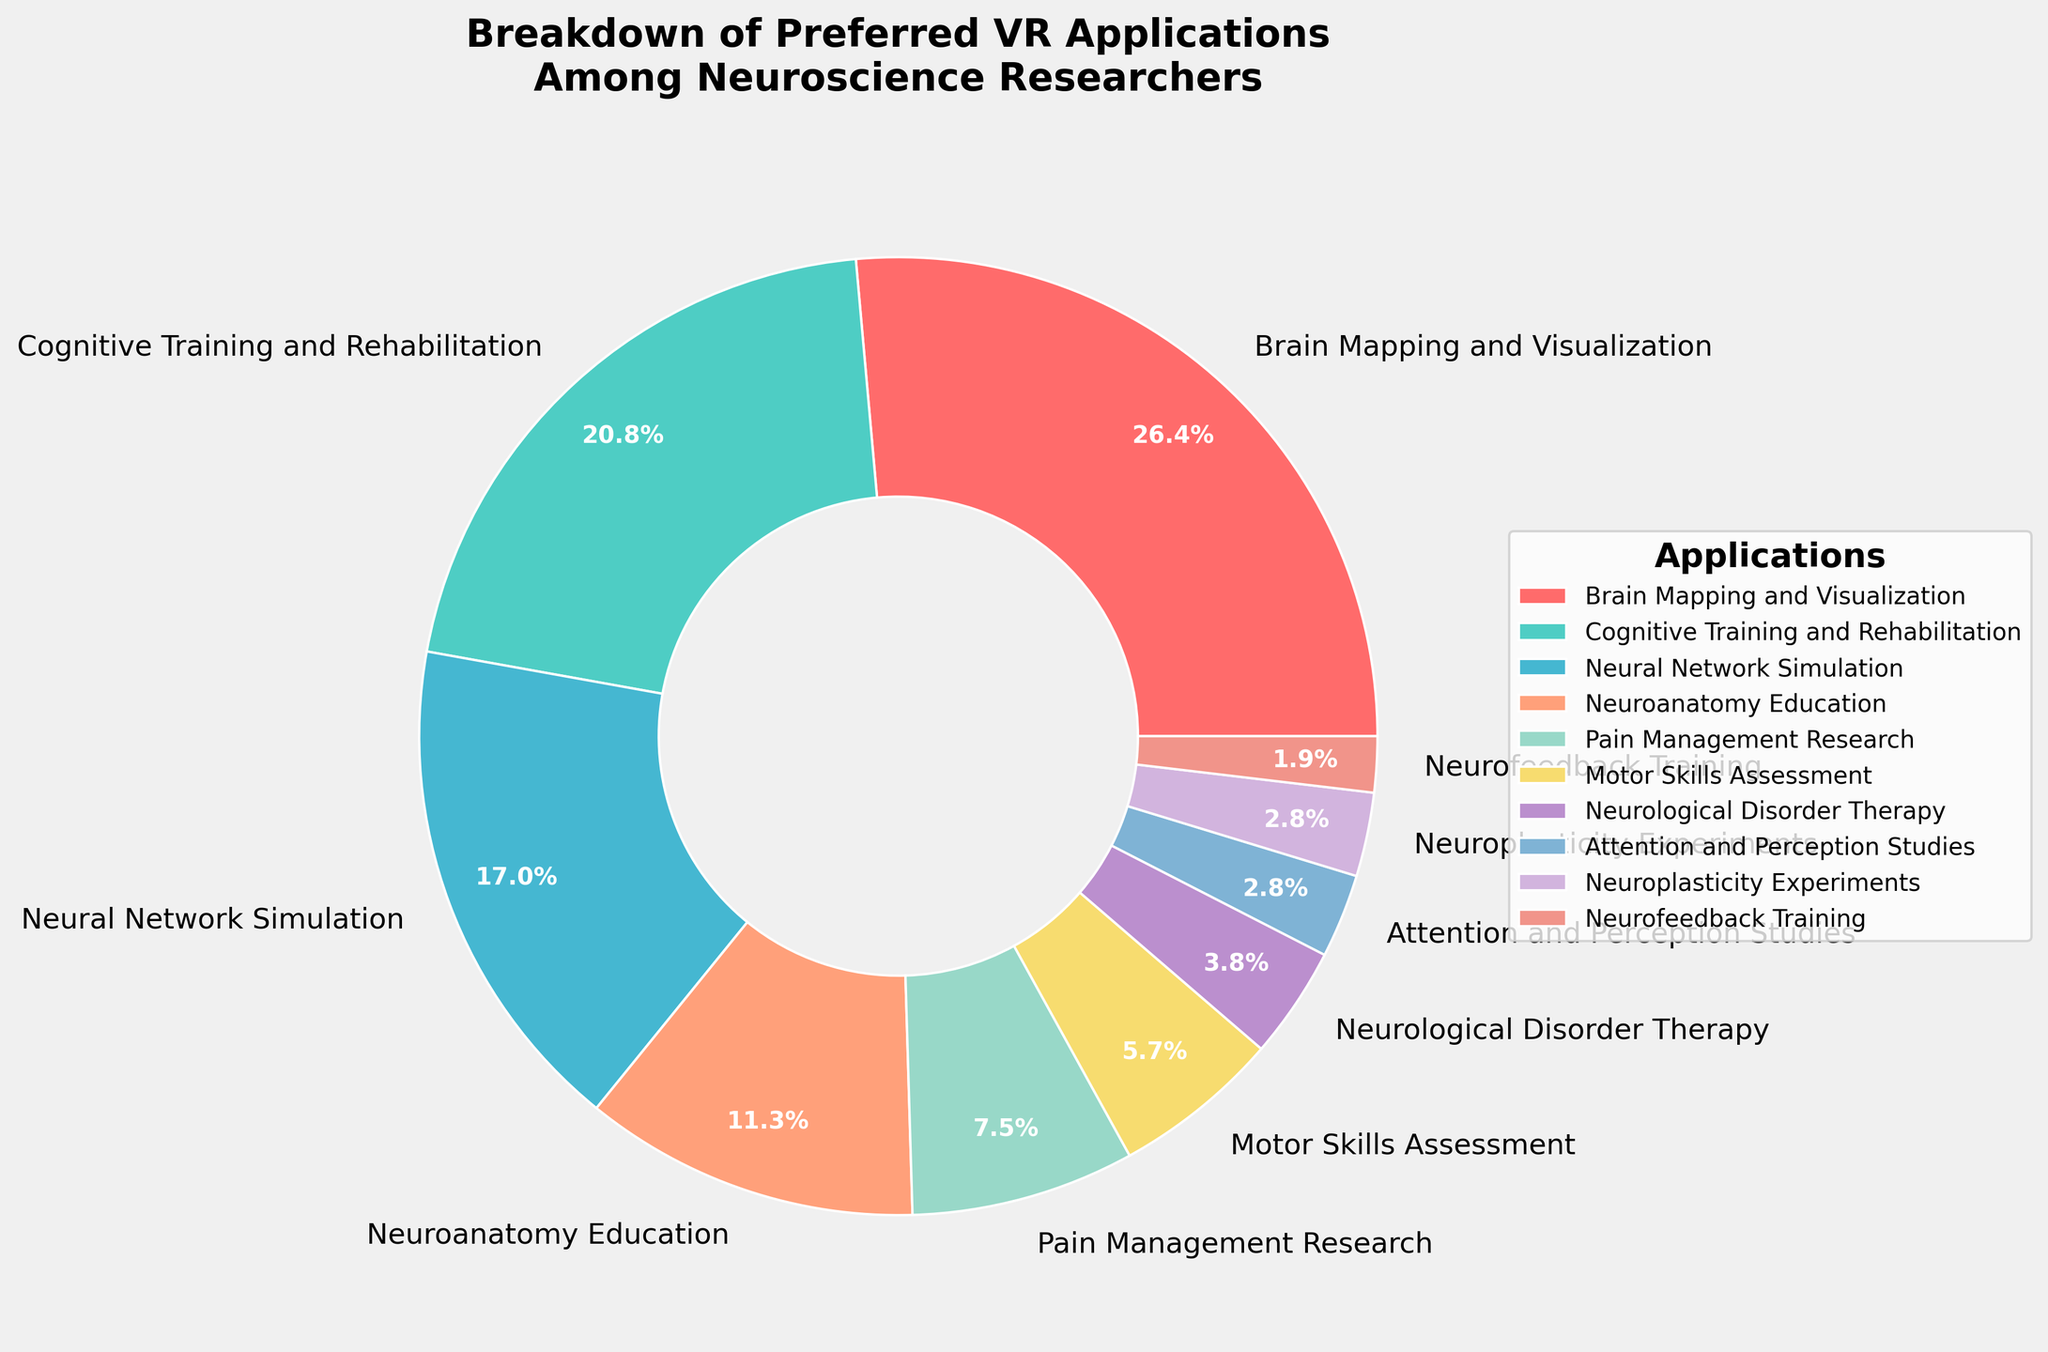What application has the highest percentage of preference among neuroscience researchers? To find this, look for the largest segment in the pie chart or the label with the highest percentage. Here, "Brain Mapping and Visualization" has the largest segment labeled 28%.
Answer: Brain Mapping and Visualization Which application category has a smaller preference than "Pain Management Research" but a larger preference than "Neurological Disorder Therapy"? "Pain Management Research" has a percentage of 8%. Categories smaller than this but larger than 4% (Neurological Disorder Therapy) will be "Motor Skills Assessment" with 6%.
Answer: Motor Skills Assessment What is the total percentage of preference for cognitive-focused applications (Cognitive Training and Rehabilitation, Attention and Perception Studies, and Neurofeedback Training)? Sum the percentages for these applications: Cognitive Training and Rehabilitation (22%), Attention and Perception Studies (3%), and Neurofeedback Training (2%). 22 + 3 + 2 = 27%.
Answer: 27% Which applications have an equal percentage of 3%? To find this, look for categories labeled with 3%. These are "Attention and Perception Studies" and "Neuroplasticity Experiments".
Answer: Attention and Perception Studies and Neuroplasticity Experiments How much more preference does "Neuroanatomy Education" have compared to "Motor Skills Assessment"? Subtract the percentage of Motor Skills Assessment (6%) from Neuroanatomy Education (12%). 12 - 6 = 6%.
Answer: 6% Which application fields have less than 10% user preference? Look for all segments or labels with percentages under 10%. These fields are Pain Management Research (8%), Motor Skills Assessment (6%), Neurological Disorder Therapy (4%), Attention and Perception Studies (3%), Neuroplasticity Experiments (3%), and Neurofeedback Training (2%).
Answer: Pain Management Research, Motor Skills Assessment, Neurological Disorder Therapy, Attention and Perception Studies, Neuroplasticity Experiments, and Neurofeedback Training What is the sum of the percentages of the top three preferred applications? Sum the percentages of the top three applications: Brain Mapping and Visualization (28%), Cognitive Training and Rehabilitation (22%), and Neural Network Simulation (18%). 28 + 22 + 18 = 68%.
Answer: 68% Does the combined preference for "Brain Mapping and Visualization" and "Neuroanatomy Education" exceed 40%? Add the percentages for both applications: Brain Mapping and Visualization (28%) and Neuroanatomy Education (12%). 28 + 12 = 40%. Since this sum equals 40%, it does not exceed 40%.
Answer: No 